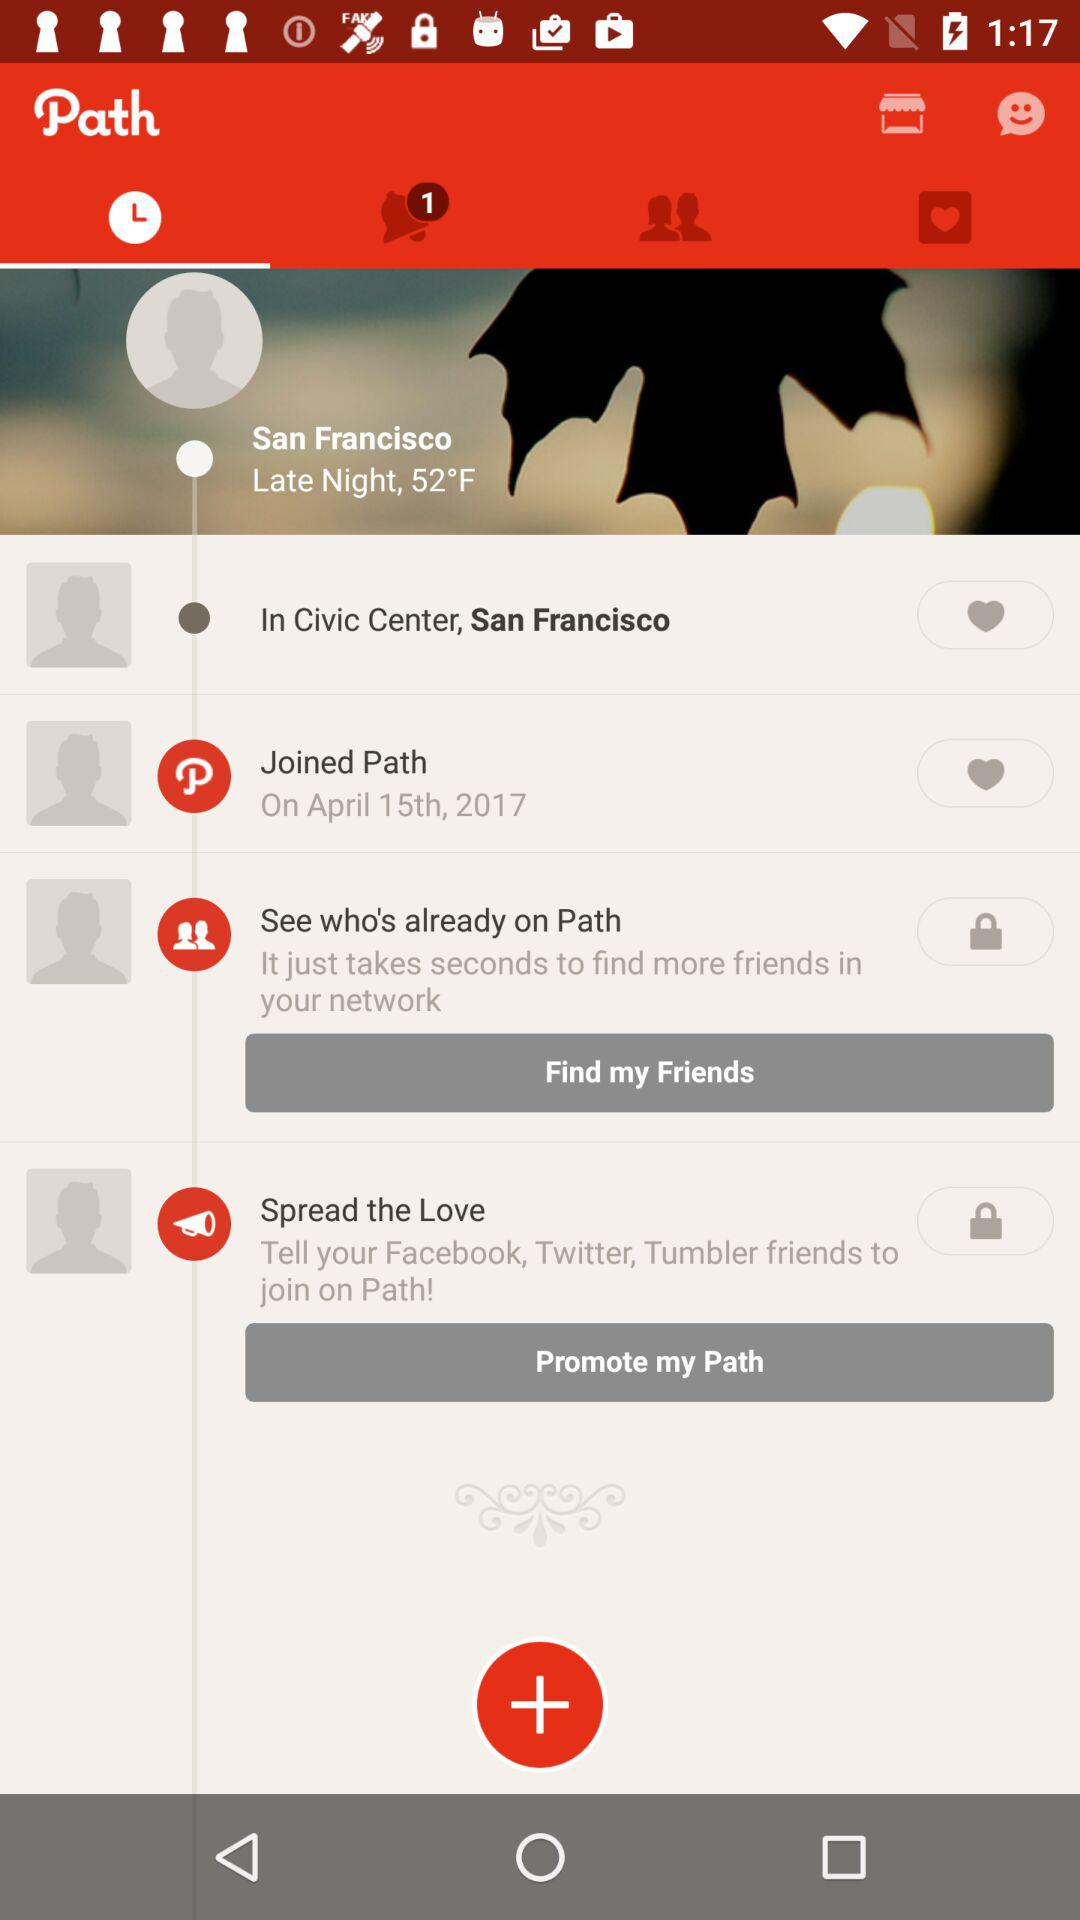What is the temperature? The temperature is 52 °F. 